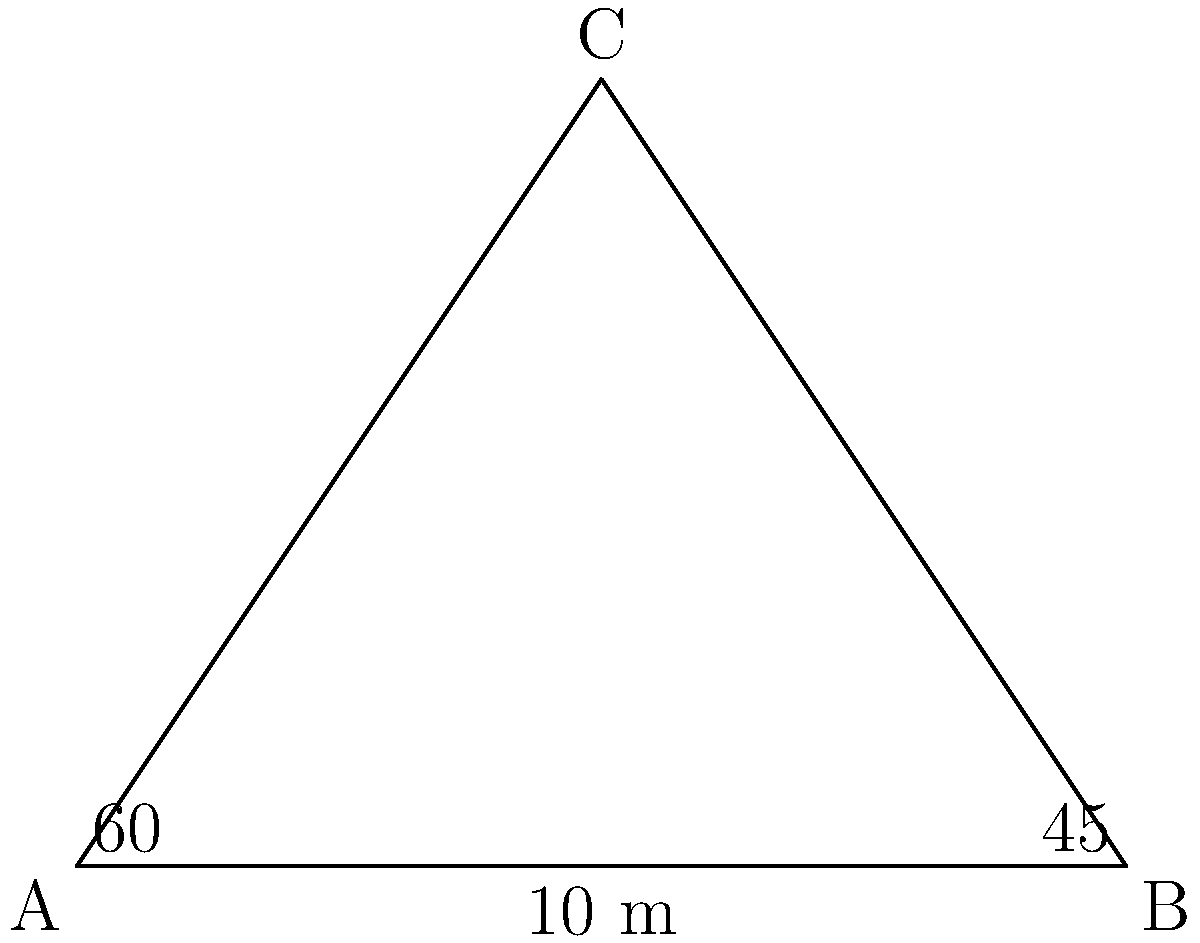En el Club de Tenis de Madrid, se están planificando dos nuevas pistas. Desde un punto de observación C, se puede ver la pista A con un ángulo de 60° y la pista B con un ángulo de 45°. Si la distancia entre las pistas A y B es de 10 metros, ¿cuál es la distancia entre el punto de observación C y la pista B? Redondea tu respuesta al metro más cercano. Para resolver este problema, utilizaremos la ley de los senos. Sigamos estos pasos:

1) En el triángulo ABC, conocemos:
   - El ángulo en A es 60°
   - El ángulo en B es 45°
   - La longitud del lado AB es 10 m

2) Calculemos el ángulo en C:
   $180° - (60° + 45°) = 75°$

3) La ley de los senos establece que:
   $\frac{a}{\sin A} = \frac{b}{\sin B} = \frac{c}{\sin C}$

   Donde a, b, c son las longitudes de los lados opuestos a los ángulos A, B, C respectivamente.

4) Queremos encontrar la longitud del lado AC (que llamaremos b). Usaremos:
   $\frac{10}{\sin 75°} = \frac{b}{\sin 45°}$

5) Despejando b:
   $b = \frac{10 \sin 45°}{\sin 75°}$

6) Calculando:
   $b = \frac{10 \cdot 0.7071}{0.9659} \approx 7.32$ m

7) Redondeando al metro más cercano: 7 m

Por lo tanto, la distancia entre el punto de observación C y la pista B es aproximadamente 7 metros.
Answer: 7 m 